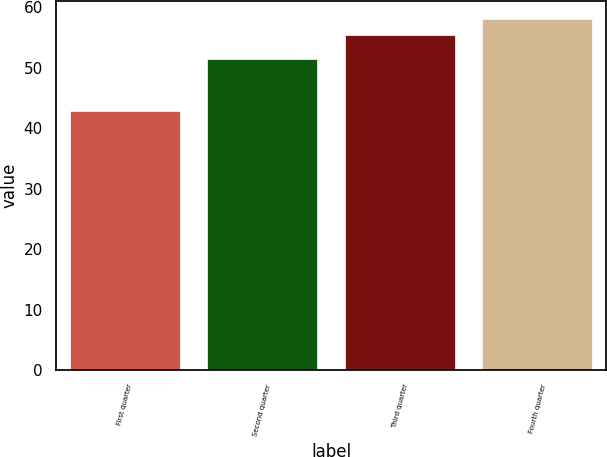Convert chart. <chart><loc_0><loc_0><loc_500><loc_500><bar_chart><fcel>First quarter<fcel>Second quarter<fcel>Third quarter<fcel>Fourth quarter<nl><fcel>42.86<fcel>51.53<fcel>55.4<fcel>58.09<nl></chart> 